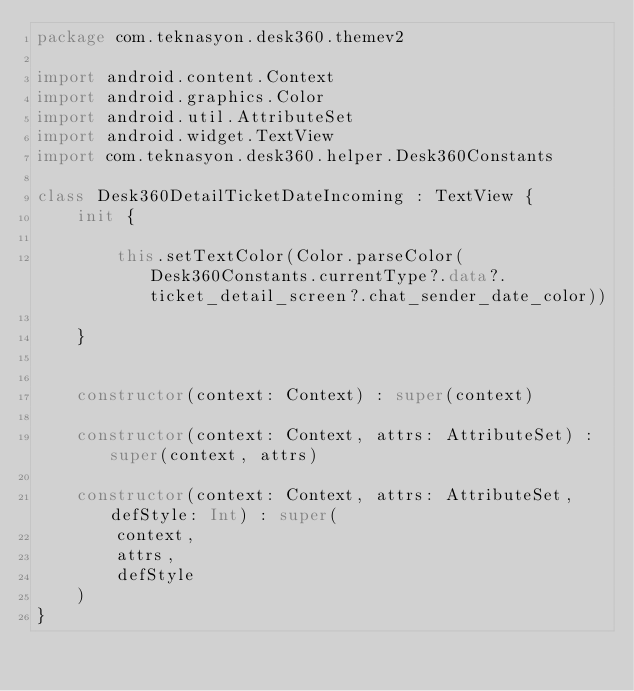<code> <loc_0><loc_0><loc_500><loc_500><_Kotlin_>package com.teknasyon.desk360.themev2

import android.content.Context
import android.graphics.Color
import android.util.AttributeSet
import android.widget.TextView
import com.teknasyon.desk360.helper.Desk360Constants

class Desk360DetailTicketDateIncoming : TextView {
    init {

        this.setTextColor(Color.parseColor(Desk360Constants.currentType?.data?.ticket_detail_screen?.chat_sender_date_color))

    }


    constructor(context: Context) : super(context)

    constructor(context: Context, attrs: AttributeSet) : super(context, attrs)

    constructor(context: Context, attrs: AttributeSet, defStyle: Int) : super(
        context,
        attrs,
        defStyle
    )
}</code> 